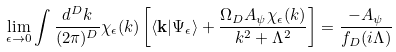Convert formula to latex. <formula><loc_0><loc_0><loc_500><loc_500>\lim _ { \epsilon \to 0 } \int \frac { d ^ { D } { k } } { ( 2 \pi ) ^ { D } } \chi _ { \epsilon } ( k ) \left [ \langle { \mathbf k } | \Psi _ { \epsilon } \rangle + \frac { \Omega _ { D } A _ { \psi } \chi _ { \epsilon } ( k ) } { k ^ { 2 } + \Lambda ^ { 2 } } \right ] = \frac { - A _ { \psi } } { f _ { D } ( i \Lambda ) }</formula> 